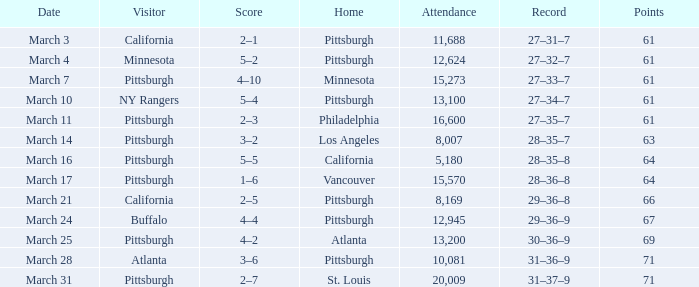What was the pittsburgh home game's score on march 3 when they had 61 points? 2–1. 